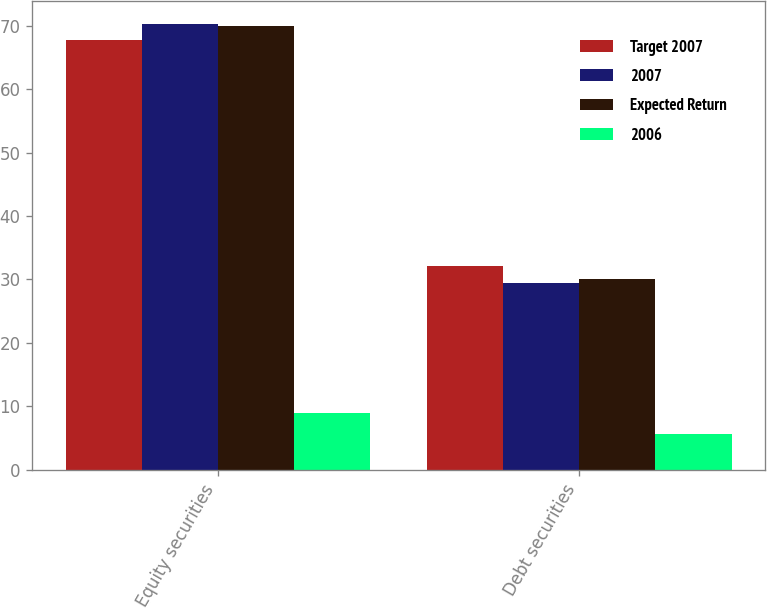Convert chart. <chart><loc_0><loc_0><loc_500><loc_500><stacked_bar_chart><ecel><fcel>Equity securities<fcel>Debt securities<nl><fcel>Target 2007<fcel>67.8<fcel>32.1<nl><fcel>2007<fcel>70.3<fcel>29.4<nl><fcel>Expected Return<fcel>70<fcel>30<nl><fcel>2006<fcel>9<fcel>5.7<nl></chart> 